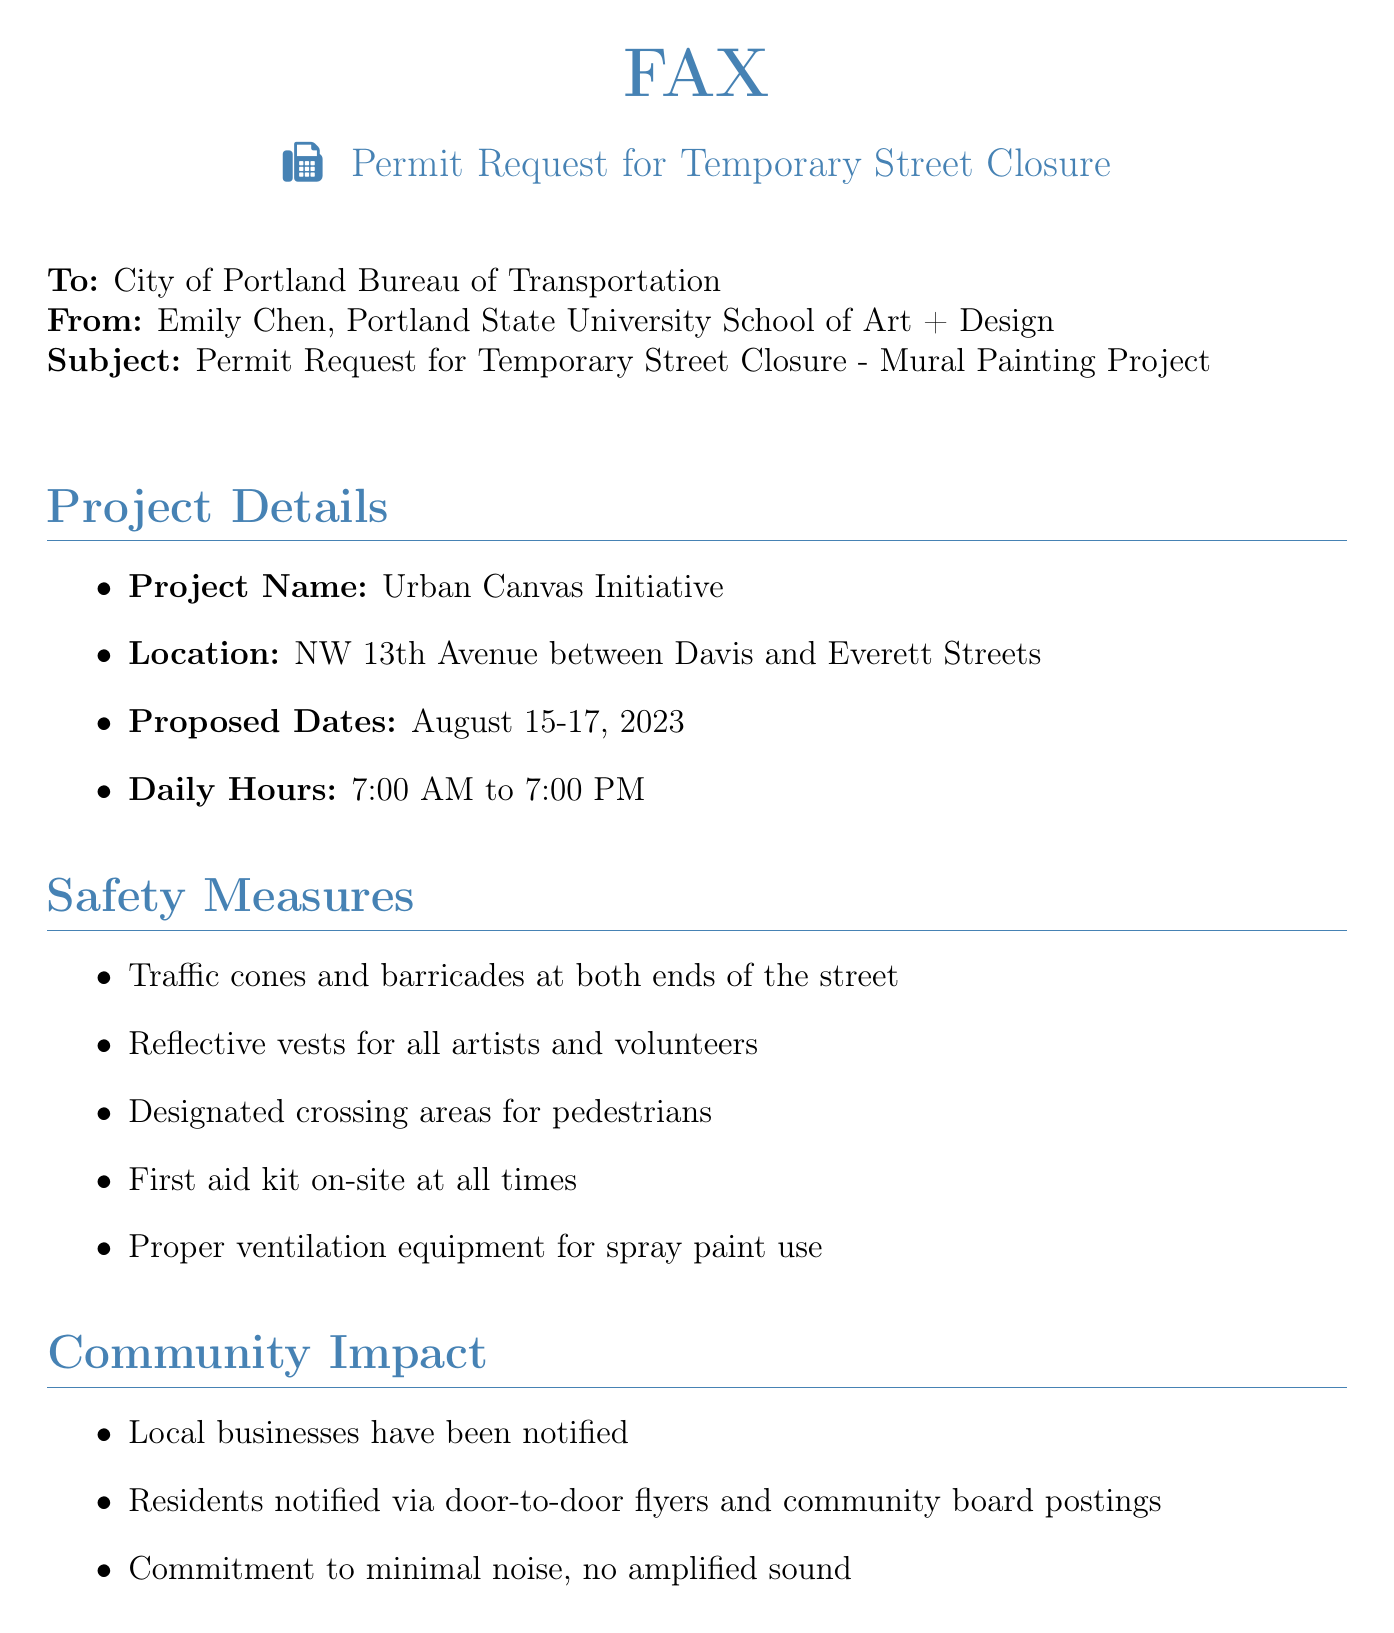What is the project name? The project name is mentioned in the project details section of the document.
Answer: Urban Canvas Initiative What are the proposed dates for the mural painting? The proposed dates are specifically stated in the project details section.
Answer: August 15-17, 2023 What time will the painting take place each day? The daily hours are provided in the project details section.
Answer: 7:00 AM to 7:00 PM What safety equipment will be available on-site? The safety measures include a list of specific safety equipment that will be present during the project.
Answer: First aid kit How will the community be notified about the project? The document lists community impact measures that involve notification methods.
Answer: Door-to-door flyers Who is the project lead? The contact information section lists the project lead's name.
Answer: Emily Chen What is the phone number for the project lead? The contact information section provides a specific phone number for communication.
Answer: (503) 555-7890 What type of sound will be present during the project? The community impact section mentions a commitment regarding noise management.
Answer: No amplified sound What are the locations for the mural painting? The project details specify the exact location for the mural.
Answer: NW 13th Avenue between Davis and Everett Streets 